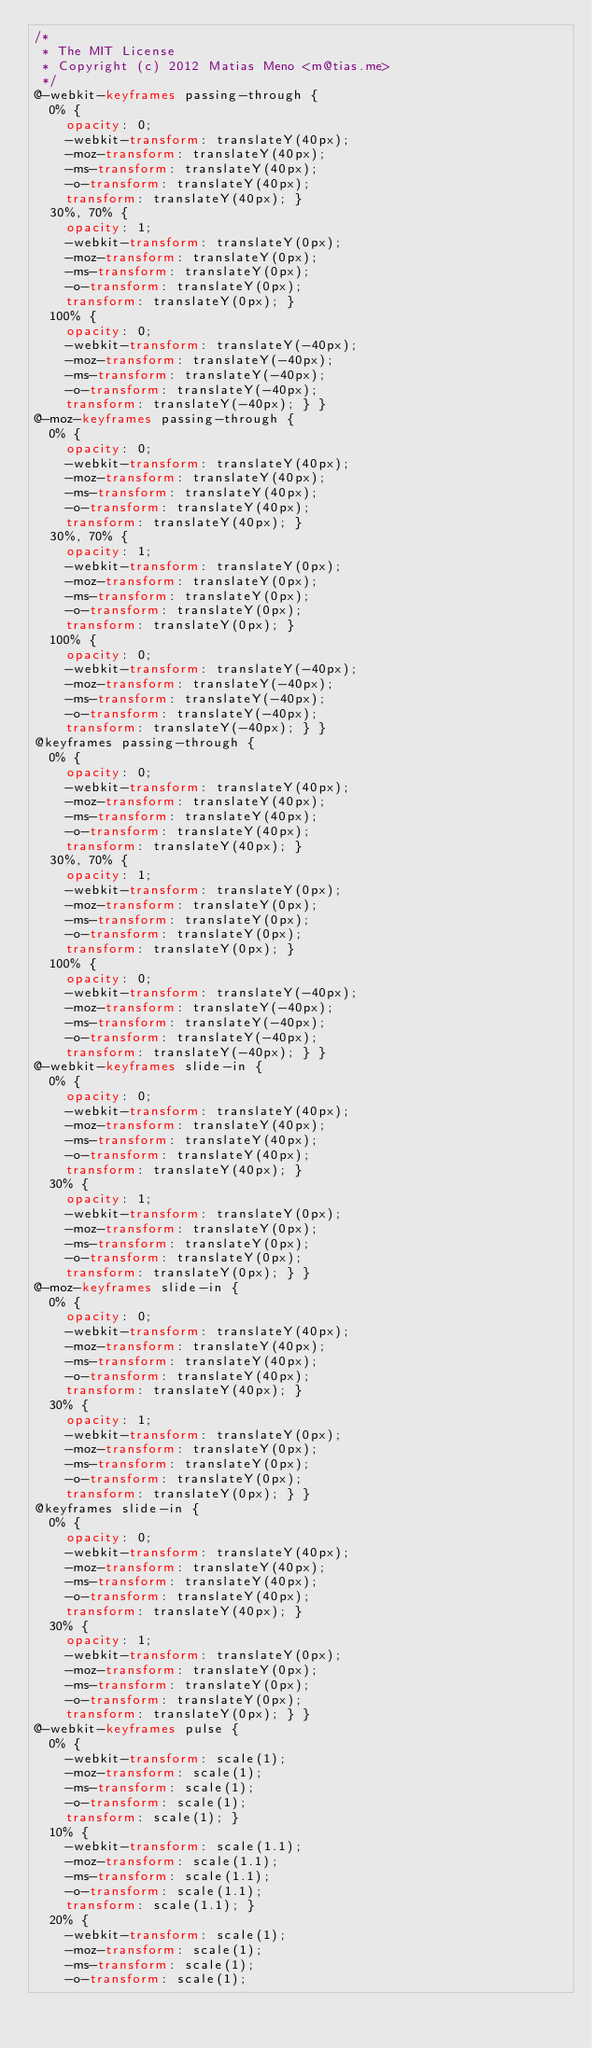<code> <loc_0><loc_0><loc_500><loc_500><_CSS_>/*
 * The MIT License
 * Copyright (c) 2012 Matias Meno <m@tias.me>
 */
@-webkit-keyframes passing-through {
  0% {
    opacity: 0;
    -webkit-transform: translateY(40px);
    -moz-transform: translateY(40px);
    -ms-transform: translateY(40px);
    -o-transform: translateY(40px);
    transform: translateY(40px); }
  30%, 70% {
    opacity: 1;
    -webkit-transform: translateY(0px);
    -moz-transform: translateY(0px);
    -ms-transform: translateY(0px);
    -o-transform: translateY(0px);
    transform: translateY(0px); }
  100% {
    opacity: 0;
    -webkit-transform: translateY(-40px);
    -moz-transform: translateY(-40px);
    -ms-transform: translateY(-40px);
    -o-transform: translateY(-40px);
    transform: translateY(-40px); } }
@-moz-keyframes passing-through {
  0% {
    opacity: 0;
    -webkit-transform: translateY(40px);
    -moz-transform: translateY(40px);
    -ms-transform: translateY(40px);
    -o-transform: translateY(40px);
    transform: translateY(40px); }
  30%, 70% {
    opacity: 1;
    -webkit-transform: translateY(0px);
    -moz-transform: translateY(0px);
    -ms-transform: translateY(0px);
    -o-transform: translateY(0px);
    transform: translateY(0px); }
  100% {
    opacity: 0;
    -webkit-transform: translateY(-40px);
    -moz-transform: translateY(-40px);
    -ms-transform: translateY(-40px);
    -o-transform: translateY(-40px);
    transform: translateY(-40px); } }
@keyframes passing-through {
  0% {
    opacity: 0;
    -webkit-transform: translateY(40px);
    -moz-transform: translateY(40px);
    -ms-transform: translateY(40px);
    -o-transform: translateY(40px);
    transform: translateY(40px); }
  30%, 70% {
    opacity: 1;
    -webkit-transform: translateY(0px);
    -moz-transform: translateY(0px);
    -ms-transform: translateY(0px);
    -o-transform: translateY(0px);
    transform: translateY(0px); }
  100% {
    opacity: 0;
    -webkit-transform: translateY(-40px);
    -moz-transform: translateY(-40px);
    -ms-transform: translateY(-40px);
    -o-transform: translateY(-40px);
    transform: translateY(-40px); } }
@-webkit-keyframes slide-in {
  0% {
    opacity: 0;
    -webkit-transform: translateY(40px);
    -moz-transform: translateY(40px);
    -ms-transform: translateY(40px);
    -o-transform: translateY(40px);
    transform: translateY(40px); }
  30% {
    opacity: 1;
    -webkit-transform: translateY(0px);
    -moz-transform: translateY(0px);
    -ms-transform: translateY(0px);
    -o-transform: translateY(0px);
    transform: translateY(0px); } }
@-moz-keyframes slide-in {
  0% {
    opacity: 0;
    -webkit-transform: translateY(40px);
    -moz-transform: translateY(40px);
    -ms-transform: translateY(40px);
    -o-transform: translateY(40px);
    transform: translateY(40px); }
  30% {
    opacity: 1;
    -webkit-transform: translateY(0px);
    -moz-transform: translateY(0px);
    -ms-transform: translateY(0px);
    -o-transform: translateY(0px);
    transform: translateY(0px); } }
@keyframes slide-in {
  0% {
    opacity: 0;
    -webkit-transform: translateY(40px);
    -moz-transform: translateY(40px);
    -ms-transform: translateY(40px);
    -o-transform: translateY(40px);
    transform: translateY(40px); }
  30% {
    opacity: 1;
    -webkit-transform: translateY(0px);
    -moz-transform: translateY(0px);
    -ms-transform: translateY(0px);
    -o-transform: translateY(0px);
    transform: translateY(0px); } }
@-webkit-keyframes pulse {
  0% {
    -webkit-transform: scale(1);
    -moz-transform: scale(1);
    -ms-transform: scale(1);
    -o-transform: scale(1);
    transform: scale(1); }
  10% {
    -webkit-transform: scale(1.1);
    -moz-transform: scale(1.1);
    -ms-transform: scale(1.1);
    -o-transform: scale(1.1);
    transform: scale(1.1); }
  20% {
    -webkit-transform: scale(1);
    -moz-transform: scale(1);
    -ms-transform: scale(1);
    -o-transform: scale(1);</code> 